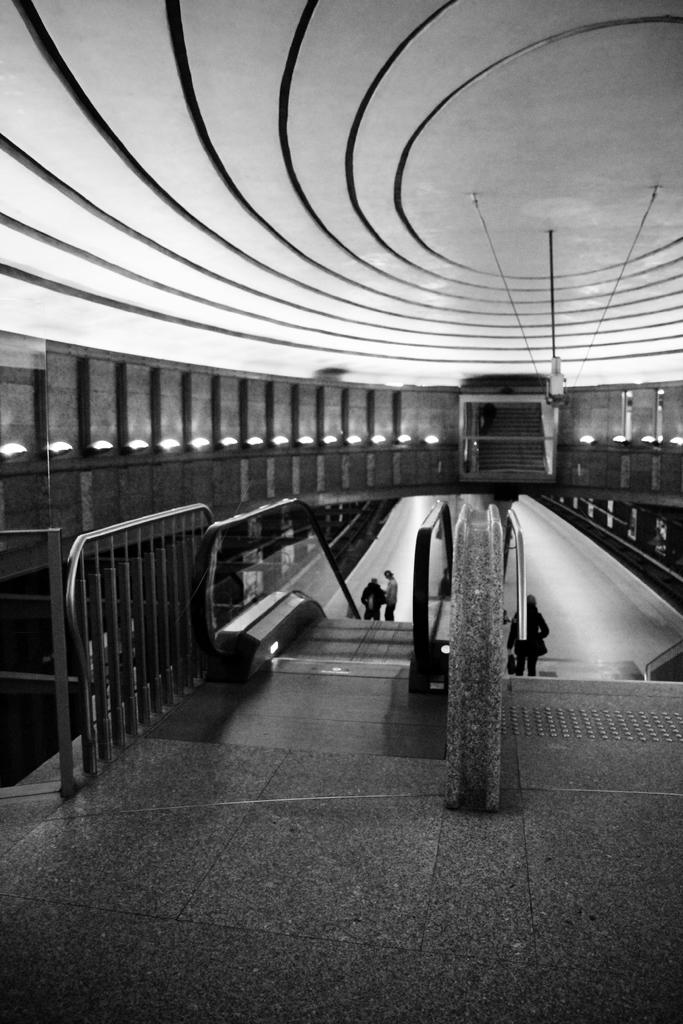What type of transportation is depicted in the image? There are escalators in the image. What are the people in the image doing? There are people standing on the escalators. What can be seen illuminating the area in the image? There are lights visible in the image. What type of garden can be seen in the image? There is no garden present in the image; it features escalators and people using them. What grade level is the part of the building shown in the image? There is no specific grade level mentioned or visible in the image, as it only shows escalators and people using them. 